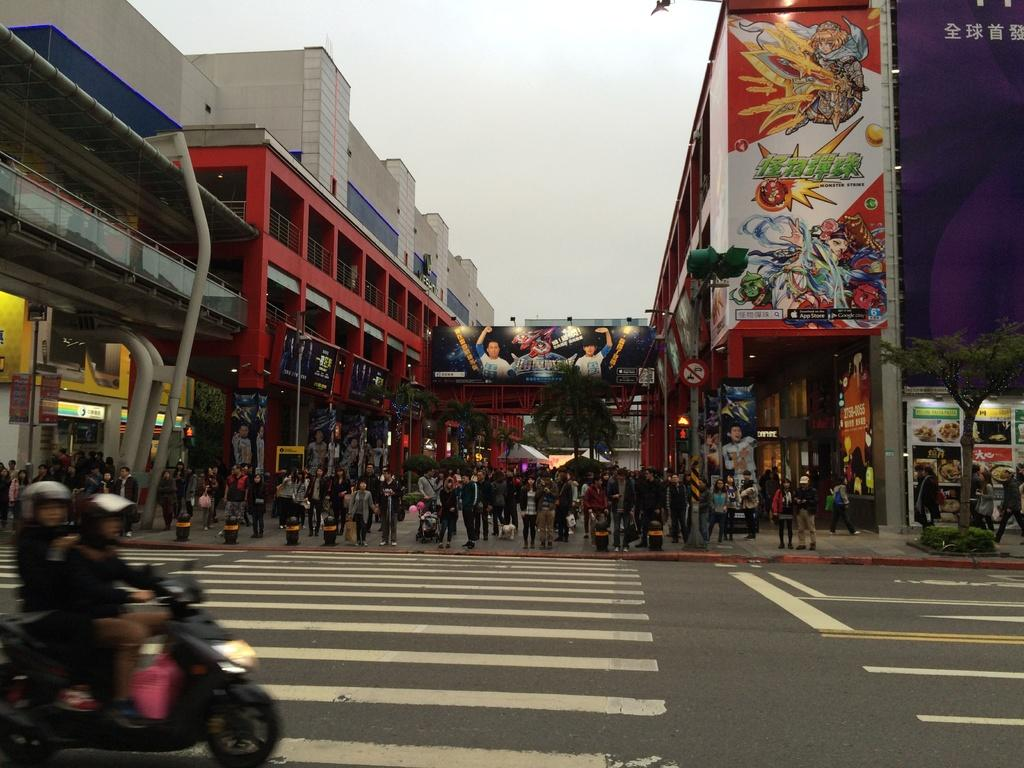What are the two people in the image doing? The two people are riding a motorcycle in the image. What can be seen in the background of the image? There is a building in the background of the image. How many people are present in the image? There are many people standing in the image. What scientific discovery can be seen in the image? There is no scientific discovery present in the image; it features two people riding a motorcycle and a building in the background. 